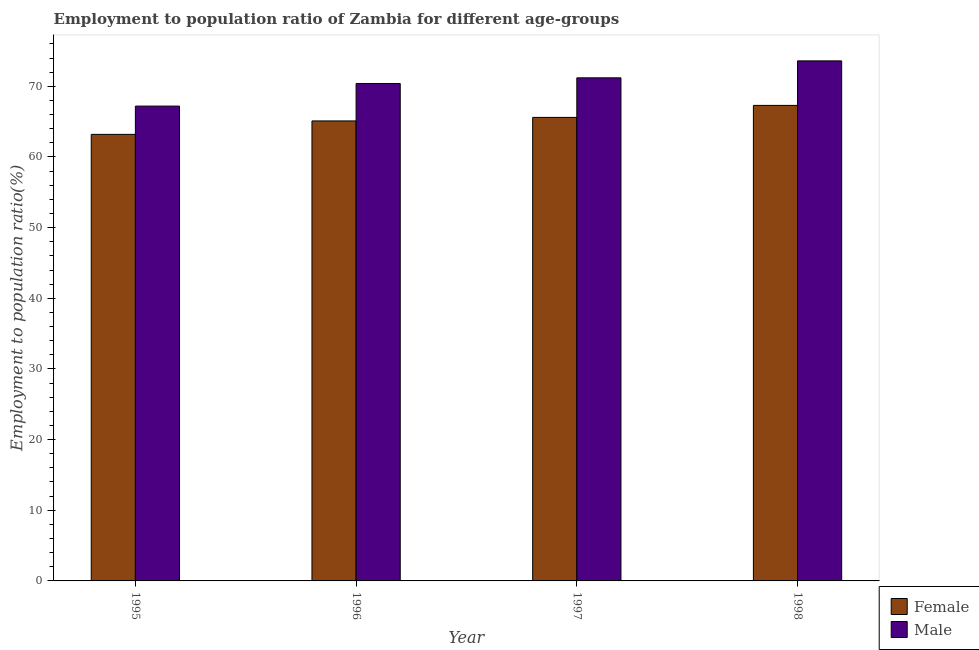How many groups of bars are there?
Ensure brevity in your answer.  4. Are the number of bars on each tick of the X-axis equal?
Offer a very short reply. Yes. How many bars are there on the 1st tick from the left?
Your answer should be compact. 2. How many bars are there on the 4th tick from the right?
Offer a terse response. 2. What is the label of the 1st group of bars from the left?
Give a very brief answer. 1995. What is the employment to population ratio(male) in 1998?
Provide a short and direct response. 73.6. Across all years, what is the maximum employment to population ratio(male)?
Give a very brief answer. 73.6. Across all years, what is the minimum employment to population ratio(female)?
Your response must be concise. 63.2. In which year was the employment to population ratio(female) maximum?
Your response must be concise. 1998. In which year was the employment to population ratio(male) minimum?
Offer a terse response. 1995. What is the total employment to population ratio(female) in the graph?
Your answer should be very brief. 261.2. What is the difference between the employment to population ratio(female) in 1995 and that in 1996?
Your response must be concise. -1.9. What is the average employment to population ratio(male) per year?
Ensure brevity in your answer.  70.6. What is the ratio of the employment to population ratio(female) in 1995 to that in 1997?
Your answer should be compact. 0.96. Is the difference between the employment to population ratio(female) in 1996 and 1998 greater than the difference between the employment to population ratio(male) in 1996 and 1998?
Your answer should be compact. No. What is the difference between the highest and the second highest employment to population ratio(female)?
Offer a very short reply. 1.7. What is the difference between the highest and the lowest employment to population ratio(male)?
Offer a very short reply. 6.4. Is the sum of the employment to population ratio(female) in 1996 and 1998 greater than the maximum employment to population ratio(male) across all years?
Keep it short and to the point. Yes. What is the difference between two consecutive major ticks on the Y-axis?
Keep it short and to the point. 10. Does the graph contain any zero values?
Your answer should be compact. No. Where does the legend appear in the graph?
Your answer should be very brief. Bottom right. How many legend labels are there?
Provide a succinct answer. 2. What is the title of the graph?
Provide a short and direct response. Employment to population ratio of Zambia for different age-groups. Does "Start a business" appear as one of the legend labels in the graph?
Your answer should be compact. No. What is the label or title of the X-axis?
Provide a short and direct response. Year. What is the Employment to population ratio(%) of Female in 1995?
Keep it short and to the point. 63.2. What is the Employment to population ratio(%) in Male in 1995?
Make the answer very short. 67.2. What is the Employment to population ratio(%) in Female in 1996?
Give a very brief answer. 65.1. What is the Employment to population ratio(%) of Male in 1996?
Your answer should be very brief. 70.4. What is the Employment to population ratio(%) of Female in 1997?
Give a very brief answer. 65.6. What is the Employment to population ratio(%) of Male in 1997?
Keep it short and to the point. 71.2. What is the Employment to population ratio(%) in Female in 1998?
Provide a short and direct response. 67.3. What is the Employment to population ratio(%) of Male in 1998?
Offer a very short reply. 73.6. Across all years, what is the maximum Employment to population ratio(%) of Female?
Offer a very short reply. 67.3. Across all years, what is the maximum Employment to population ratio(%) in Male?
Your answer should be very brief. 73.6. Across all years, what is the minimum Employment to population ratio(%) of Female?
Offer a very short reply. 63.2. Across all years, what is the minimum Employment to population ratio(%) of Male?
Make the answer very short. 67.2. What is the total Employment to population ratio(%) in Female in the graph?
Your answer should be compact. 261.2. What is the total Employment to population ratio(%) of Male in the graph?
Your answer should be very brief. 282.4. What is the difference between the Employment to population ratio(%) in Male in 1995 and that in 1996?
Provide a succinct answer. -3.2. What is the difference between the Employment to population ratio(%) in Female in 1995 and that in 1997?
Provide a short and direct response. -2.4. What is the difference between the Employment to population ratio(%) in Male in 1995 and that in 1997?
Ensure brevity in your answer.  -4. What is the difference between the Employment to population ratio(%) in Female in 1995 and that in 1998?
Your response must be concise. -4.1. What is the difference between the Employment to population ratio(%) of Male in 1995 and that in 1998?
Provide a succinct answer. -6.4. What is the difference between the Employment to population ratio(%) in Female in 1996 and that in 1997?
Provide a succinct answer. -0.5. What is the difference between the Employment to population ratio(%) in Male in 1996 and that in 1998?
Keep it short and to the point. -3.2. What is the difference between the Employment to population ratio(%) of Male in 1997 and that in 1998?
Your response must be concise. -2.4. What is the difference between the Employment to population ratio(%) of Female in 1997 and the Employment to population ratio(%) of Male in 1998?
Offer a terse response. -8. What is the average Employment to population ratio(%) in Female per year?
Ensure brevity in your answer.  65.3. What is the average Employment to population ratio(%) of Male per year?
Your answer should be very brief. 70.6. In the year 1995, what is the difference between the Employment to population ratio(%) in Female and Employment to population ratio(%) in Male?
Offer a very short reply. -4. In the year 1996, what is the difference between the Employment to population ratio(%) of Female and Employment to population ratio(%) of Male?
Ensure brevity in your answer.  -5.3. What is the ratio of the Employment to population ratio(%) in Female in 1995 to that in 1996?
Give a very brief answer. 0.97. What is the ratio of the Employment to population ratio(%) in Male in 1995 to that in 1996?
Your answer should be very brief. 0.95. What is the ratio of the Employment to population ratio(%) of Female in 1995 to that in 1997?
Give a very brief answer. 0.96. What is the ratio of the Employment to population ratio(%) in Male in 1995 to that in 1997?
Your response must be concise. 0.94. What is the ratio of the Employment to population ratio(%) of Female in 1995 to that in 1998?
Provide a short and direct response. 0.94. What is the ratio of the Employment to population ratio(%) in Male in 1995 to that in 1998?
Ensure brevity in your answer.  0.91. What is the ratio of the Employment to population ratio(%) in Female in 1996 to that in 1997?
Provide a short and direct response. 0.99. What is the ratio of the Employment to population ratio(%) of Male in 1996 to that in 1997?
Your answer should be very brief. 0.99. What is the ratio of the Employment to population ratio(%) of Female in 1996 to that in 1998?
Give a very brief answer. 0.97. What is the ratio of the Employment to population ratio(%) in Male in 1996 to that in 1998?
Your answer should be very brief. 0.96. What is the ratio of the Employment to population ratio(%) in Female in 1997 to that in 1998?
Ensure brevity in your answer.  0.97. What is the ratio of the Employment to population ratio(%) in Male in 1997 to that in 1998?
Offer a terse response. 0.97. What is the difference between the highest and the lowest Employment to population ratio(%) of Female?
Provide a short and direct response. 4.1. What is the difference between the highest and the lowest Employment to population ratio(%) of Male?
Your answer should be very brief. 6.4. 